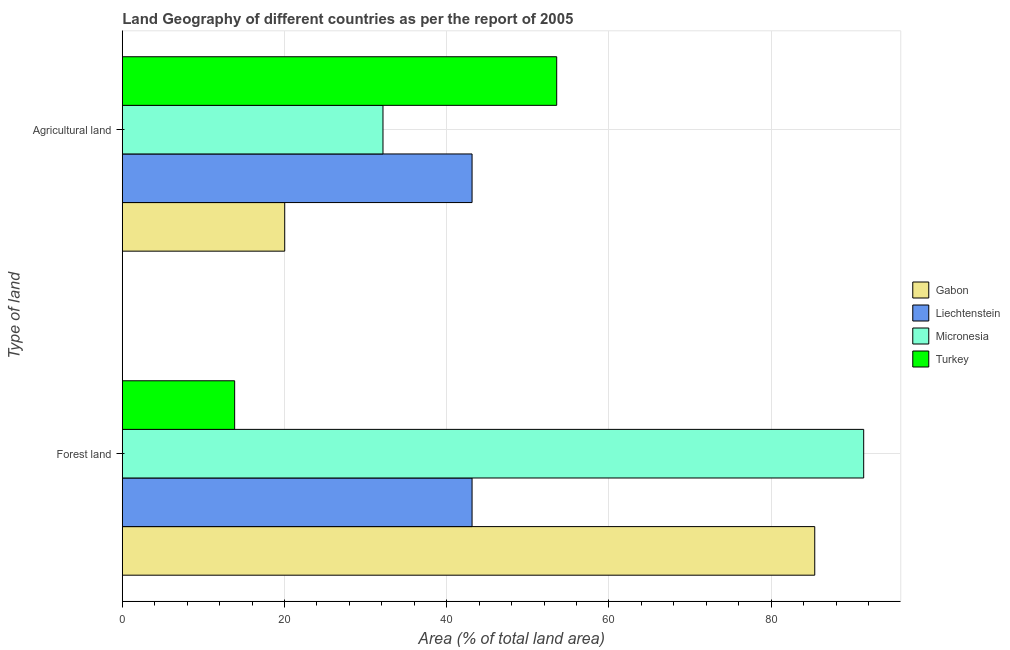How many groups of bars are there?
Your response must be concise. 2. Are the number of bars per tick equal to the number of legend labels?
Your response must be concise. Yes. Are the number of bars on each tick of the Y-axis equal?
Offer a very short reply. Yes. How many bars are there on the 2nd tick from the top?
Your answer should be compact. 4. What is the label of the 1st group of bars from the top?
Your response must be concise. Agricultural land. What is the percentage of land area under agriculture in Micronesia?
Provide a succinct answer. 32.14. Across all countries, what is the maximum percentage of land area under forests?
Keep it short and to the point. 91.41. Across all countries, what is the minimum percentage of land area under agriculture?
Offer a very short reply. 20.03. What is the total percentage of land area under forests in the graph?
Your answer should be compact. 233.77. What is the difference between the percentage of land area under agriculture in Micronesia and that in Gabon?
Provide a short and direct response. 12.12. What is the difference between the percentage of land area under agriculture in Turkey and the percentage of land area under forests in Liechtenstein?
Your answer should be compact. 10.44. What is the average percentage of land area under agriculture per country?
Your answer should be compact. 37.21. In how many countries, is the percentage of land area under forests greater than 52 %?
Give a very brief answer. 2. What is the ratio of the percentage of land area under agriculture in Micronesia to that in Liechtenstein?
Give a very brief answer. 0.75. Is the percentage of land area under agriculture in Liechtenstein less than that in Turkey?
Offer a very short reply. Yes. In how many countries, is the percentage of land area under forests greater than the average percentage of land area under forests taken over all countries?
Offer a very short reply. 2. What does the 2nd bar from the top in Forest land represents?
Offer a terse response. Micronesia. What does the 2nd bar from the bottom in Agricultural land represents?
Provide a short and direct response. Liechtenstein. How many countries are there in the graph?
Your answer should be compact. 4. Are the values on the major ticks of X-axis written in scientific E-notation?
Keep it short and to the point. No. Does the graph contain any zero values?
Offer a terse response. No. Does the graph contain grids?
Your response must be concise. Yes. Where does the legend appear in the graph?
Ensure brevity in your answer.  Center right. How are the legend labels stacked?
Your answer should be compact. Vertical. What is the title of the graph?
Offer a very short reply. Land Geography of different countries as per the report of 2005. Does "French Polynesia" appear as one of the legend labels in the graph?
Your response must be concise. No. What is the label or title of the X-axis?
Offer a very short reply. Area (% of total land area). What is the label or title of the Y-axis?
Make the answer very short. Type of land. What is the Area (% of total land area) of Gabon in Forest land?
Offer a terse response. 85.38. What is the Area (% of total land area) in Liechtenstein in Forest land?
Keep it short and to the point. 43.12. What is the Area (% of total land area) of Micronesia in Forest land?
Your answer should be compact. 91.41. What is the Area (% of total land area) of Turkey in Forest land?
Offer a terse response. 13.85. What is the Area (% of total land area) of Gabon in Agricultural land?
Ensure brevity in your answer.  20.03. What is the Area (% of total land area) in Liechtenstein in Agricultural land?
Provide a succinct answer. 43.12. What is the Area (% of total land area) of Micronesia in Agricultural land?
Offer a very short reply. 32.14. What is the Area (% of total land area) in Turkey in Agricultural land?
Your response must be concise. 53.56. Across all Type of land, what is the maximum Area (% of total land area) in Gabon?
Give a very brief answer. 85.38. Across all Type of land, what is the maximum Area (% of total land area) of Liechtenstein?
Give a very brief answer. 43.12. Across all Type of land, what is the maximum Area (% of total land area) in Micronesia?
Keep it short and to the point. 91.41. Across all Type of land, what is the maximum Area (% of total land area) in Turkey?
Ensure brevity in your answer.  53.56. Across all Type of land, what is the minimum Area (% of total land area) of Gabon?
Your response must be concise. 20.03. Across all Type of land, what is the minimum Area (% of total land area) in Liechtenstein?
Your response must be concise. 43.12. Across all Type of land, what is the minimum Area (% of total land area) of Micronesia?
Provide a succinct answer. 32.14. Across all Type of land, what is the minimum Area (% of total land area) in Turkey?
Make the answer very short. 13.85. What is the total Area (% of total land area) in Gabon in the graph?
Keep it short and to the point. 105.41. What is the total Area (% of total land area) in Liechtenstein in the graph?
Make the answer very short. 86.25. What is the total Area (% of total land area) in Micronesia in the graph?
Your response must be concise. 123.56. What is the total Area (% of total land area) of Turkey in the graph?
Ensure brevity in your answer.  67.42. What is the difference between the Area (% of total land area) in Gabon in Forest land and that in Agricultural land?
Keep it short and to the point. 65.35. What is the difference between the Area (% of total land area) in Liechtenstein in Forest land and that in Agricultural land?
Offer a very short reply. 0. What is the difference between the Area (% of total land area) in Micronesia in Forest land and that in Agricultural land?
Keep it short and to the point. 59.27. What is the difference between the Area (% of total land area) of Turkey in Forest land and that in Agricultural land?
Give a very brief answer. -39.71. What is the difference between the Area (% of total land area) of Gabon in Forest land and the Area (% of total land area) of Liechtenstein in Agricultural land?
Your answer should be compact. 42.26. What is the difference between the Area (% of total land area) in Gabon in Forest land and the Area (% of total land area) in Micronesia in Agricultural land?
Offer a terse response. 53.24. What is the difference between the Area (% of total land area) of Gabon in Forest land and the Area (% of total land area) of Turkey in Agricultural land?
Your answer should be very brief. 31.82. What is the difference between the Area (% of total land area) of Liechtenstein in Forest land and the Area (% of total land area) of Micronesia in Agricultural land?
Offer a terse response. 10.98. What is the difference between the Area (% of total land area) in Liechtenstein in Forest land and the Area (% of total land area) in Turkey in Agricultural land?
Provide a short and direct response. -10.44. What is the difference between the Area (% of total land area) in Micronesia in Forest land and the Area (% of total land area) in Turkey in Agricultural land?
Ensure brevity in your answer.  37.85. What is the average Area (% of total land area) in Gabon per Type of land?
Offer a terse response. 52.7. What is the average Area (% of total land area) in Liechtenstein per Type of land?
Make the answer very short. 43.12. What is the average Area (% of total land area) of Micronesia per Type of land?
Your answer should be compact. 61.78. What is the average Area (% of total land area) in Turkey per Type of land?
Ensure brevity in your answer.  33.71. What is the difference between the Area (% of total land area) of Gabon and Area (% of total land area) of Liechtenstein in Forest land?
Your response must be concise. 42.26. What is the difference between the Area (% of total land area) in Gabon and Area (% of total land area) in Micronesia in Forest land?
Provide a succinct answer. -6.03. What is the difference between the Area (% of total land area) of Gabon and Area (% of total land area) of Turkey in Forest land?
Your response must be concise. 71.53. What is the difference between the Area (% of total land area) of Liechtenstein and Area (% of total land area) of Micronesia in Forest land?
Your answer should be very brief. -48.29. What is the difference between the Area (% of total land area) in Liechtenstein and Area (% of total land area) in Turkey in Forest land?
Offer a terse response. 29.27. What is the difference between the Area (% of total land area) in Micronesia and Area (% of total land area) in Turkey in Forest land?
Offer a very short reply. 77.56. What is the difference between the Area (% of total land area) of Gabon and Area (% of total land area) of Liechtenstein in Agricultural land?
Offer a terse response. -23.1. What is the difference between the Area (% of total land area) of Gabon and Area (% of total land area) of Micronesia in Agricultural land?
Your answer should be very brief. -12.12. What is the difference between the Area (% of total land area) of Gabon and Area (% of total land area) of Turkey in Agricultural land?
Your answer should be very brief. -33.54. What is the difference between the Area (% of total land area) in Liechtenstein and Area (% of total land area) in Micronesia in Agricultural land?
Provide a succinct answer. 10.98. What is the difference between the Area (% of total land area) of Liechtenstein and Area (% of total land area) of Turkey in Agricultural land?
Your response must be concise. -10.44. What is the difference between the Area (% of total land area) in Micronesia and Area (% of total land area) in Turkey in Agricultural land?
Offer a very short reply. -21.42. What is the ratio of the Area (% of total land area) in Gabon in Forest land to that in Agricultural land?
Provide a short and direct response. 4.26. What is the ratio of the Area (% of total land area) of Liechtenstein in Forest land to that in Agricultural land?
Offer a terse response. 1. What is the ratio of the Area (% of total land area) in Micronesia in Forest land to that in Agricultural land?
Ensure brevity in your answer.  2.84. What is the ratio of the Area (% of total land area) of Turkey in Forest land to that in Agricultural land?
Ensure brevity in your answer.  0.26. What is the difference between the highest and the second highest Area (% of total land area) of Gabon?
Your answer should be very brief. 65.35. What is the difference between the highest and the second highest Area (% of total land area) in Micronesia?
Provide a succinct answer. 59.27. What is the difference between the highest and the second highest Area (% of total land area) of Turkey?
Offer a very short reply. 39.71. What is the difference between the highest and the lowest Area (% of total land area) of Gabon?
Offer a terse response. 65.35. What is the difference between the highest and the lowest Area (% of total land area) in Micronesia?
Provide a short and direct response. 59.27. What is the difference between the highest and the lowest Area (% of total land area) of Turkey?
Provide a short and direct response. 39.71. 